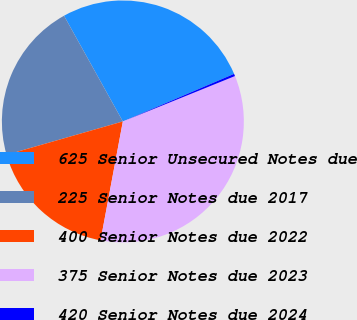Convert chart. <chart><loc_0><loc_0><loc_500><loc_500><pie_chart><fcel>625 Senior Unsecured Notes due<fcel>225 Senior Notes due 2017<fcel>400 Senior Notes due 2022<fcel>375 Senior Notes due 2023<fcel>420 Senior Notes due 2024<nl><fcel>26.65%<fcel>21.36%<fcel>17.61%<fcel>34.07%<fcel>0.31%<nl></chart> 